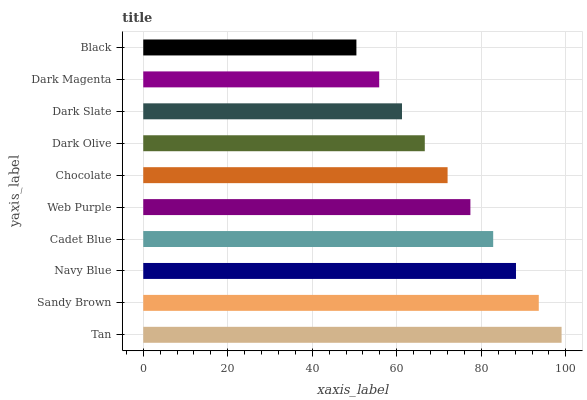Is Black the minimum?
Answer yes or no. Yes. Is Tan the maximum?
Answer yes or no. Yes. Is Sandy Brown the minimum?
Answer yes or no. No. Is Sandy Brown the maximum?
Answer yes or no. No. Is Tan greater than Sandy Brown?
Answer yes or no. Yes. Is Sandy Brown less than Tan?
Answer yes or no. Yes. Is Sandy Brown greater than Tan?
Answer yes or no. No. Is Tan less than Sandy Brown?
Answer yes or no. No. Is Web Purple the high median?
Answer yes or no. Yes. Is Chocolate the low median?
Answer yes or no. Yes. Is Sandy Brown the high median?
Answer yes or no. No. Is Web Purple the low median?
Answer yes or no. No. 